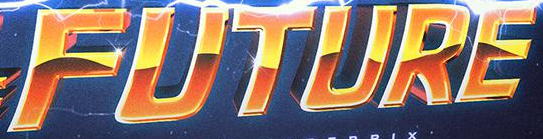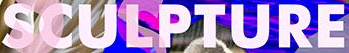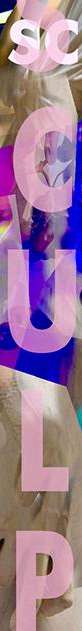Transcribe the words shown in these images in order, separated by a semicolon. FUTURE; SCULPTURE; SCULP 